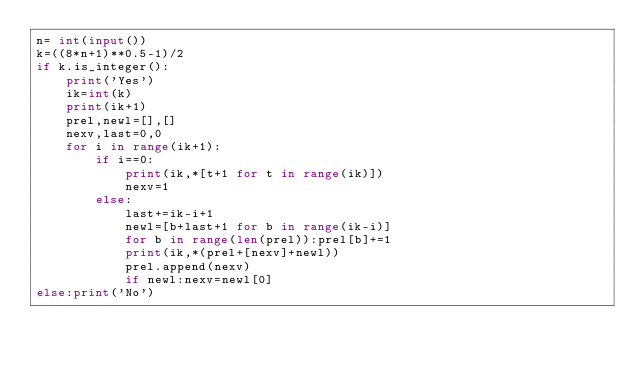<code> <loc_0><loc_0><loc_500><loc_500><_Python_>n= int(input())
k=((8*n+1)**0.5-1)/2
if k.is_integer():
    print('Yes')
    ik=int(k)
    print(ik+1)
    prel,newl=[],[]
    nexv,last=0,0
    for i in range(ik+1):
        if i==0:
            print(ik,*[t+1 for t in range(ik)])
            nexv=1
        else:
            last+=ik-i+1
            newl=[b+last+1 for b in range(ik-i)]
            for b in range(len(prel)):prel[b]+=1
            print(ik,*(prel+[nexv]+newl))
            prel.append(nexv)
            if newl:nexv=newl[0]
else:print('No')</code> 